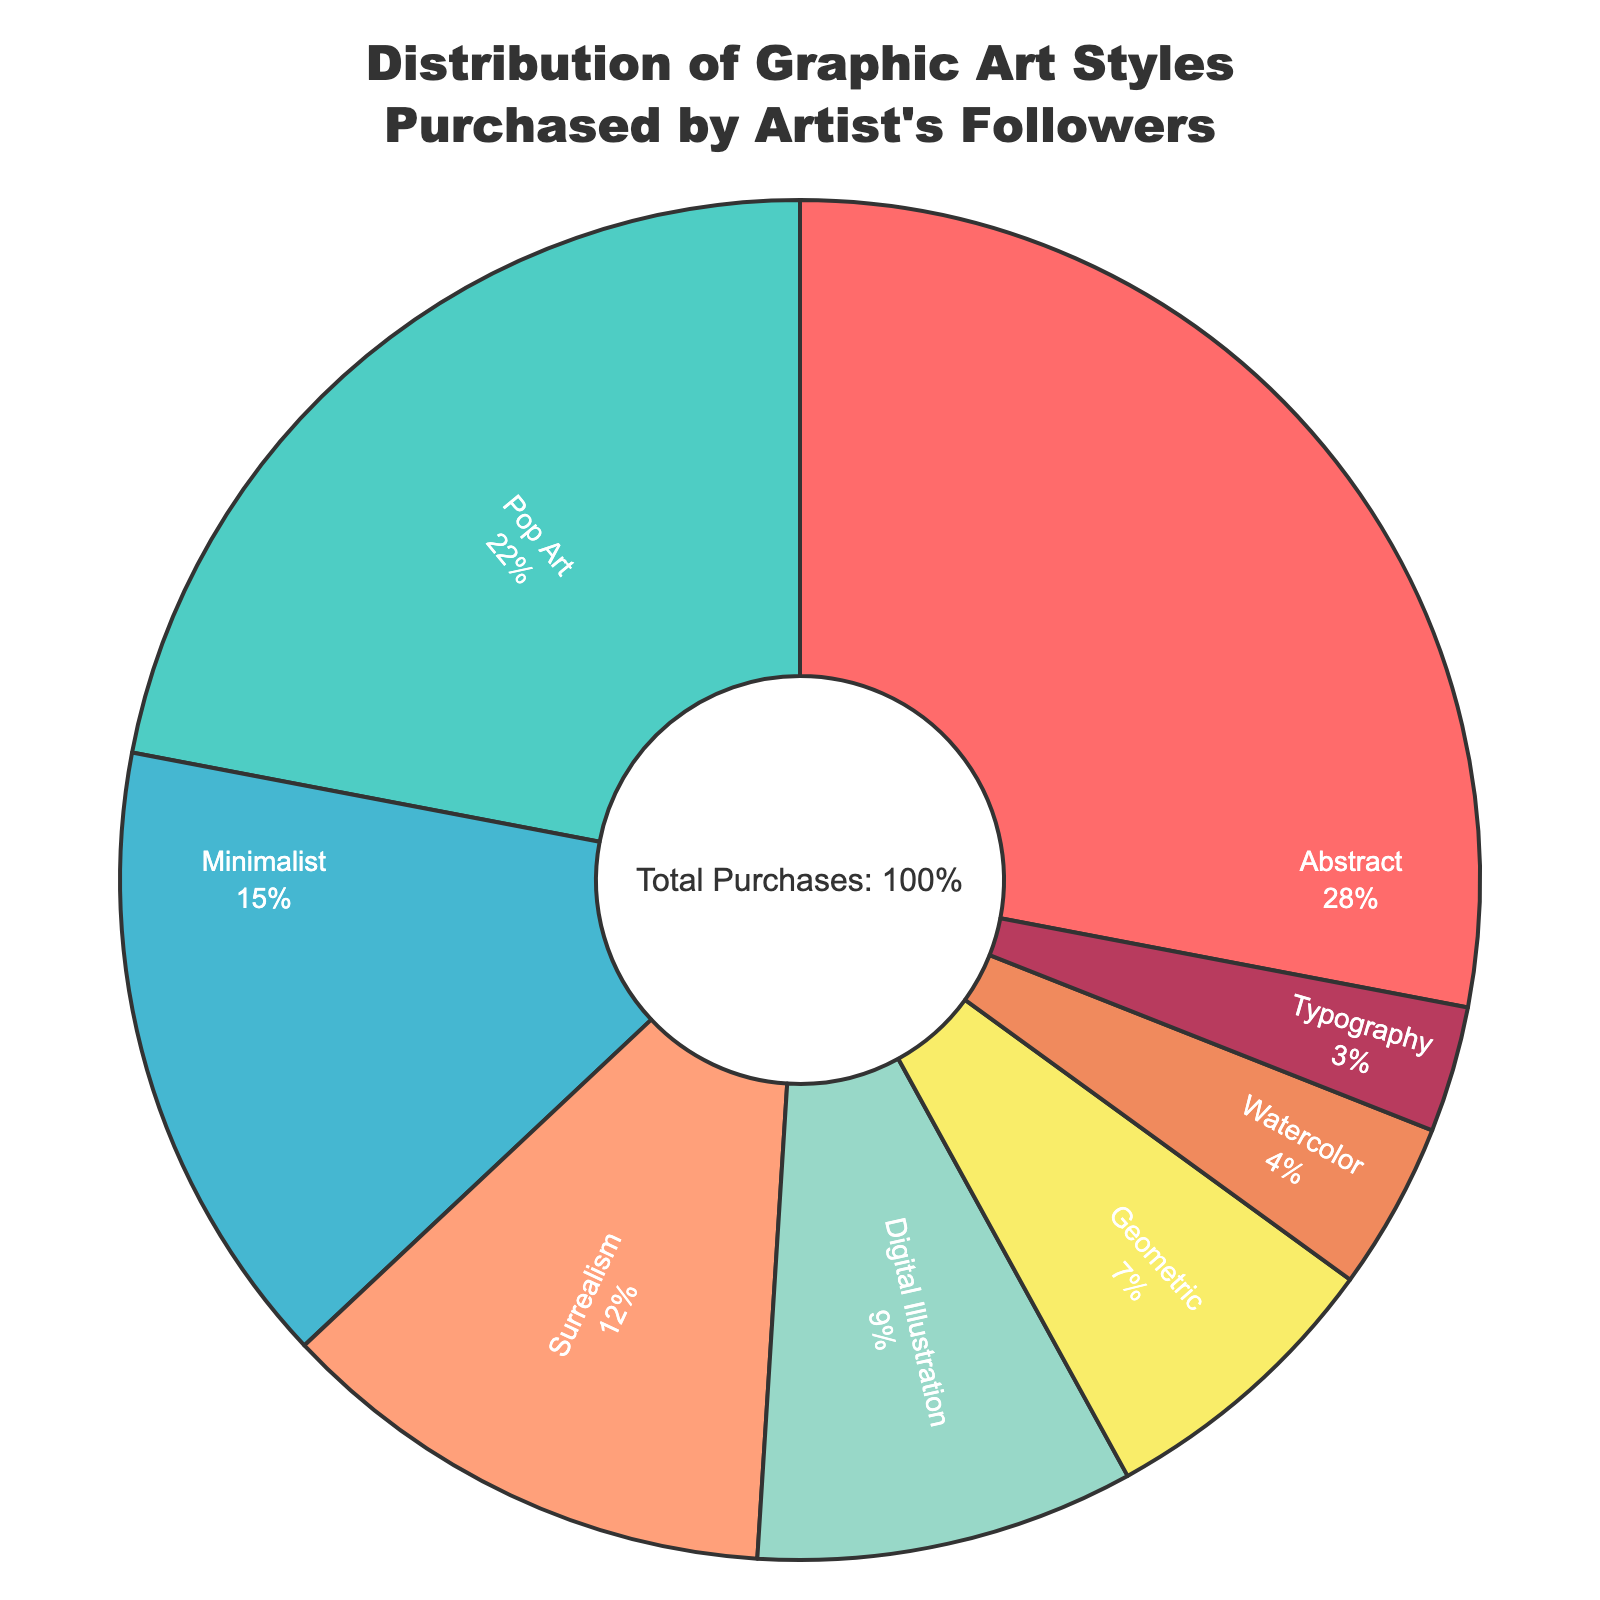What percentage of purchases are for Abstract and Pop Art styles combined? The percentages for Abstract and Pop Art are 28% and 22%, respectively. To find the combined percentage, add these two values: 28 + 22 = 50%.
Answer: 50% Which art style has the smallest percentage of purchases? Looking at the percentages, Typography has the smallest value at 3%.
Answer: Typography Among Abstract, Digital Illustration, and Watercolor, which one has the highest percentage of purchases? The percentages for Abstract, Digital Illustration, and Watercolor are 28%, 9%, and 4%, respectively. The highest percentage among them is 28% (Abstract).
Answer: Abstract Is Surrealism more popular than Minimalist? The percentage for Surrealism is 12%, while the percentage for Minimalist is 15%. Since 12% is less than 15%, Surrealism is less popular than Minimalist.
Answer: No By how much does the percentage of purchases for Pop Art exceed that of Geometric? The percentage for Pop Art is 22% and for Geometric it is 7%. The difference is 22 - 7 = 15%.
Answer: 15% What is the total percentage of purchases for non-digital art styles (excluding Digital Illustration)? The percentages for non-digital art styles are Abstract (28%), Pop Art (22%), Minimalist (15%), Surrealism (12%), Geometric (7%), Watercolor (4%), and Typography (3%). Sum these values: 28 + 22 + 15 + 12 + 7 + 4 + 3 = 91%.
Answer: 91% Which art style has a nearly equal percentage of purchases to the combined purchases of Watercolor and Typography? Watercolor and Typography have percentages of 4% and 3%, respectively. Combined, this makes 4 + 3 = 7%. The Geometric art style also has a percentage of 7%, making it nearly equal.
Answer: Geometric Are there more purchases for Surrealism than for Digital Illustration and Watercolor combined? The percentage for Surrealism is 12%. The combined percentage for Digital Illustration and Watercolor is 9% + 4% = 13%. Since 12% is less than 13%, there are fewer purchases for Surrealism.
Answer: No What color represents the Minimalist style in the pie chart? According to the provided color list and the sequence of art styles, Minimalist is represented by the fifth color in the list, which is '#98D8C8' (a light blue-green). Translate this to its visual color: light blue-green.
Answer: Light blue-green 